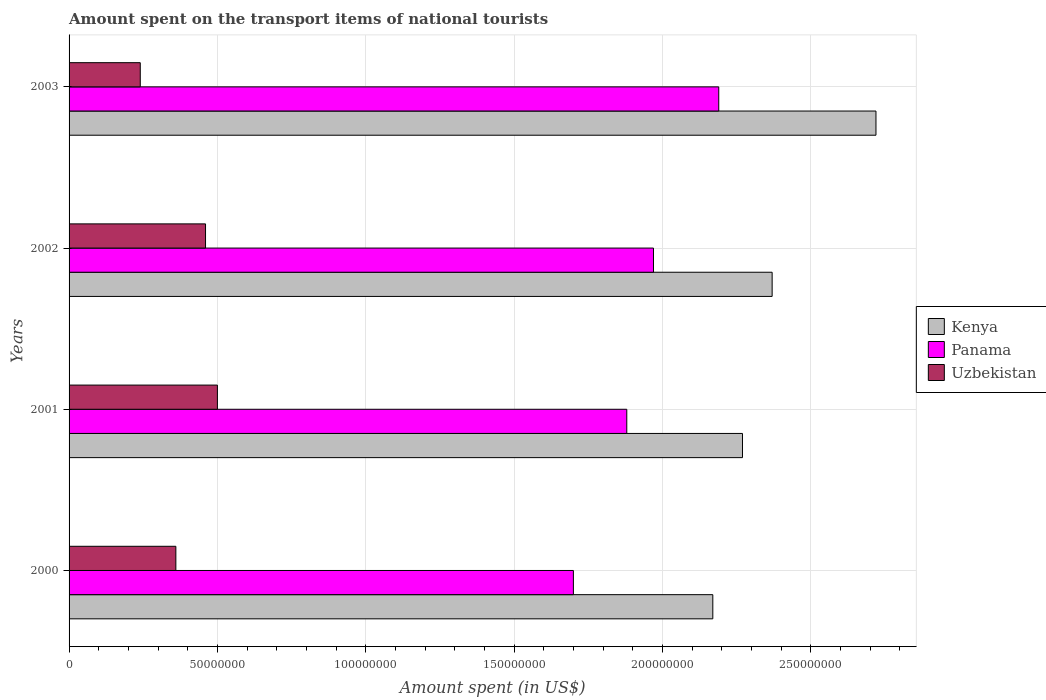How many different coloured bars are there?
Provide a short and direct response. 3. How many groups of bars are there?
Provide a short and direct response. 4. Are the number of bars per tick equal to the number of legend labels?
Give a very brief answer. Yes. How many bars are there on the 4th tick from the top?
Keep it short and to the point. 3. How many bars are there on the 2nd tick from the bottom?
Your answer should be compact. 3. What is the amount spent on the transport items of national tourists in Panama in 2003?
Ensure brevity in your answer.  2.19e+08. Across all years, what is the maximum amount spent on the transport items of national tourists in Uzbekistan?
Provide a short and direct response. 5.00e+07. Across all years, what is the minimum amount spent on the transport items of national tourists in Uzbekistan?
Your answer should be very brief. 2.40e+07. What is the total amount spent on the transport items of national tourists in Uzbekistan in the graph?
Offer a very short reply. 1.56e+08. What is the difference between the amount spent on the transport items of national tourists in Uzbekistan in 2002 and that in 2003?
Offer a very short reply. 2.20e+07. What is the average amount spent on the transport items of national tourists in Uzbekistan per year?
Offer a very short reply. 3.90e+07. In the year 2002, what is the difference between the amount spent on the transport items of national tourists in Uzbekistan and amount spent on the transport items of national tourists in Panama?
Ensure brevity in your answer.  -1.51e+08. What is the ratio of the amount spent on the transport items of national tourists in Uzbekistan in 2001 to that in 2002?
Ensure brevity in your answer.  1.09. Is the amount spent on the transport items of national tourists in Kenya in 2001 less than that in 2003?
Ensure brevity in your answer.  Yes. What is the difference between the highest and the second highest amount spent on the transport items of national tourists in Uzbekistan?
Give a very brief answer. 4.00e+06. What is the difference between the highest and the lowest amount spent on the transport items of national tourists in Panama?
Give a very brief answer. 4.90e+07. In how many years, is the amount spent on the transport items of national tourists in Uzbekistan greater than the average amount spent on the transport items of national tourists in Uzbekistan taken over all years?
Give a very brief answer. 2. What does the 2nd bar from the top in 2001 represents?
Keep it short and to the point. Panama. What does the 2nd bar from the bottom in 2000 represents?
Your answer should be very brief. Panama. Are all the bars in the graph horizontal?
Offer a very short reply. Yes. How many years are there in the graph?
Your response must be concise. 4. Are the values on the major ticks of X-axis written in scientific E-notation?
Offer a very short reply. No. Does the graph contain any zero values?
Ensure brevity in your answer.  No. How are the legend labels stacked?
Offer a very short reply. Vertical. What is the title of the graph?
Keep it short and to the point. Amount spent on the transport items of national tourists. What is the label or title of the X-axis?
Offer a terse response. Amount spent (in US$). What is the Amount spent (in US$) in Kenya in 2000?
Provide a succinct answer. 2.17e+08. What is the Amount spent (in US$) in Panama in 2000?
Give a very brief answer. 1.70e+08. What is the Amount spent (in US$) in Uzbekistan in 2000?
Your answer should be compact. 3.60e+07. What is the Amount spent (in US$) in Kenya in 2001?
Ensure brevity in your answer.  2.27e+08. What is the Amount spent (in US$) of Panama in 2001?
Ensure brevity in your answer.  1.88e+08. What is the Amount spent (in US$) of Uzbekistan in 2001?
Give a very brief answer. 5.00e+07. What is the Amount spent (in US$) of Kenya in 2002?
Your response must be concise. 2.37e+08. What is the Amount spent (in US$) in Panama in 2002?
Make the answer very short. 1.97e+08. What is the Amount spent (in US$) of Uzbekistan in 2002?
Provide a short and direct response. 4.60e+07. What is the Amount spent (in US$) of Kenya in 2003?
Your answer should be compact. 2.72e+08. What is the Amount spent (in US$) in Panama in 2003?
Keep it short and to the point. 2.19e+08. What is the Amount spent (in US$) of Uzbekistan in 2003?
Your answer should be very brief. 2.40e+07. Across all years, what is the maximum Amount spent (in US$) of Kenya?
Offer a terse response. 2.72e+08. Across all years, what is the maximum Amount spent (in US$) of Panama?
Keep it short and to the point. 2.19e+08. Across all years, what is the minimum Amount spent (in US$) in Kenya?
Give a very brief answer. 2.17e+08. Across all years, what is the minimum Amount spent (in US$) in Panama?
Provide a short and direct response. 1.70e+08. Across all years, what is the minimum Amount spent (in US$) in Uzbekistan?
Make the answer very short. 2.40e+07. What is the total Amount spent (in US$) of Kenya in the graph?
Your answer should be very brief. 9.53e+08. What is the total Amount spent (in US$) of Panama in the graph?
Give a very brief answer. 7.74e+08. What is the total Amount spent (in US$) in Uzbekistan in the graph?
Make the answer very short. 1.56e+08. What is the difference between the Amount spent (in US$) in Kenya in 2000 and that in 2001?
Provide a succinct answer. -1.00e+07. What is the difference between the Amount spent (in US$) of Panama in 2000 and that in 2001?
Keep it short and to the point. -1.80e+07. What is the difference between the Amount spent (in US$) of Uzbekistan in 2000 and that in 2001?
Your answer should be very brief. -1.40e+07. What is the difference between the Amount spent (in US$) in Kenya in 2000 and that in 2002?
Your answer should be very brief. -2.00e+07. What is the difference between the Amount spent (in US$) of Panama in 2000 and that in 2002?
Offer a very short reply. -2.70e+07. What is the difference between the Amount spent (in US$) in Uzbekistan in 2000 and that in 2002?
Provide a short and direct response. -1.00e+07. What is the difference between the Amount spent (in US$) of Kenya in 2000 and that in 2003?
Keep it short and to the point. -5.50e+07. What is the difference between the Amount spent (in US$) in Panama in 2000 and that in 2003?
Give a very brief answer. -4.90e+07. What is the difference between the Amount spent (in US$) of Kenya in 2001 and that in 2002?
Provide a short and direct response. -1.00e+07. What is the difference between the Amount spent (in US$) of Panama in 2001 and that in 2002?
Provide a short and direct response. -9.00e+06. What is the difference between the Amount spent (in US$) in Kenya in 2001 and that in 2003?
Your response must be concise. -4.50e+07. What is the difference between the Amount spent (in US$) in Panama in 2001 and that in 2003?
Provide a short and direct response. -3.10e+07. What is the difference between the Amount spent (in US$) in Uzbekistan in 2001 and that in 2003?
Keep it short and to the point. 2.60e+07. What is the difference between the Amount spent (in US$) in Kenya in 2002 and that in 2003?
Provide a short and direct response. -3.50e+07. What is the difference between the Amount spent (in US$) of Panama in 2002 and that in 2003?
Offer a very short reply. -2.20e+07. What is the difference between the Amount spent (in US$) in Uzbekistan in 2002 and that in 2003?
Your response must be concise. 2.20e+07. What is the difference between the Amount spent (in US$) in Kenya in 2000 and the Amount spent (in US$) in Panama in 2001?
Your answer should be compact. 2.90e+07. What is the difference between the Amount spent (in US$) of Kenya in 2000 and the Amount spent (in US$) of Uzbekistan in 2001?
Ensure brevity in your answer.  1.67e+08. What is the difference between the Amount spent (in US$) in Panama in 2000 and the Amount spent (in US$) in Uzbekistan in 2001?
Your response must be concise. 1.20e+08. What is the difference between the Amount spent (in US$) in Kenya in 2000 and the Amount spent (in US$) in Panama in 2002?
Provide a succinct answer. 2.00e+07. What is the difference between the Amount spent (in US$) in Kenya in 2000 and the Amount spent (in US$) in Uzbekistan in 2002?
Keep it short and to the point. 1.71e+08. What is the difference between the Amount spent (in US$) of Panama in 2000 and the Amount spent (in US$) of Uzbekistan in 2002?
Your answer should be very brief. 1.24e+08. What is the difference between the Amount spent (in US$) of Kenya in 2000 and the Amount spent (in US$) of Panama in 2003?
Make the answer very short. -2.00e+06. What is the difference between the Amount spent (in US$) of Kenya in 2000 and the Amount spent (in US$) of Uzbekistan in 2003?
Offer a very short reply. 1.93e+08. What is the difference between the Amount spent (in US$) in Panama in 2000 and the Amount spent (in US$) in Uzbekistan in 2003?
Your answer should be compact. 1.46e+08. What is the difference between the Amount spent (in US$) of Kenya in 2001 and the Amount spent (in US$) of Panama in 2002?
Your answer should be very brief. 3.00e+07. What is the difference between the Amount spent (in US$) in Kenya in 2001 and the Amount spent (in US$) in Uzbekistan in 2002?
Ensure brevity in your answer.  1.81e+08. What is the difference between the Amount spent (in US$) in Panama in 2001 and the Amount spent (in US$) in Uzbekistan in 2002?
Provide a short and direct response. 1.42e+08. What is the difference between the Amount spent (in US$) of Kenya in 2001 and the Amount spent (in US$) of Panama in 2003?
Your response must be concise. 8.00e+06. What is the difference between the Amount spent (in US$) of Kenya in 2001 and the Amount spent (in US$) of Uzbekistan in 2003?
Your answer should be compact. 2.03e+08. What is the difference between the Amount spent (in US$) in Panama in 2001 and the Amount spent (in US$) in Uzbekistan in 2003?
Your answer should be compact. 1.64e+08. What is the difference between the Amount spent (in US$) in Kenya in 2002 and the Amount spent (in US$) in Panama in 2003?
Offer a very short reply. 1.80e+07. What is the difference between the Amount spent (in US$) in Kenya in 2002 and the Amount spent (in US$) in Uzbekistan in 2003?
Offer a terse response. 2.13e+08. What is the difference between the Amount spent (in US$) of Panama in 2002 and the Amount spent (in US$) of Uzbekistan in 2003?
Your answer should be very brief. 1.73e+08. What is the average Amount spent (in US$) in Kenya per year?
Make the answer very short. 2.38e+08. What is the average Amount spent (in US$) of Panama per year?
Offer a very short reply. 1.94e+08. What is the average Amount spent (in US$) in Uzbekistan per year?
Your answer should be very brief. 3.90e+07. In the year 2000, what is the difference between the Amount spent (in US$) of Kenya and Amount spent (in US$) of Panama?
Your answer should be very brief. 4.70e+07. In the year 2000, what is the difference between the Amount spent (in US$) of Kenya and Amount spent (in US$) of Uzbekistan?
Ensure brevity in your answer.  1.81e+08. In the year 2000, what is the difference between the Amount spent (in US$) of Panama and Amount spent (in US$) of Uzbekistan?
Keep it short and to the point. 1.34e+08. In the year 2001, what is the difference between the Amount spent (in US$) of Kenya and Amount spent (in US$) of Panama?
Offer a very short reply. 3.90e+07. In the year 2001, what is the difference between the Amount spent (in US$) in Kenya and Amount spent (in US$) in Uzbekistan?
Your answer should be compact. 1.77e+08. In the year 2001, what is the difference between the Amount spent (in US$) in Panama and Amount spent (in US$) in Uzbekistan?
Offer a very short reply. 1.38e+08. In the year 2002, what is the difference between the Amount spent (in US$) of Kenya and Amount spent (in US$) of Panama?
Provide a short and direct response. 4.00e+07. In the year 2002, what is the difference between the Amount spent (in US$) in Kenya and Amount spent (in US$) in Uzbekistan?
Keep it short and to the point. 1.91e+08. In the year 2002, what is the difference between the Amount spent (in US$) of Panama and Amount spent (in US$) of Uzbekistan?
Offer a very short reply. 1.51e+08. In the year 2003, what is the difference between the Amount spent (in US$) in Kenya and Amount spent (in US$) in Panama?
Make the answer very short. 5.30e+07. In the year 2003, what is the difference between the Amount spent (in US$) of Kenya and Amount spent (in US$) of Uzbekistan?
Make the answer very short. 2.48e+08. In the year 2003, what is the difference between the Amount spent (in US$) of Panama and Amount spent (in US$) of Uzbekistan?
Provide a short and direct response. 1.95e+08. What is the ratio of the Amount spent (in US$) of Kenya in 2000 to that in 2001?
Your answer should be compact. 0.96. What is the ratio of the Amount spent (in US$) in Panama in 2000 to that in 2001?
Offer a very short reply. 0.9. What is the ratio of the Amount spent (in US$) in Uzbekistan in 2000 to that in 2001?
Your answer should be very brief. 0.72. What is the ratio of the Amount spent (in US$) in Kenya in 2000 to that in 2002?
Offer a terse response. 0.92. What is the ratio of the Amount spent (in US$) of Panama in 2000 to that in 2002?
Your answer should be very brief. 0.86. What is the ratio of the Amount spent (in US$) of Uzbekistan in 2000 to that in 2002?
Offer a very short reply. 0.78. What is the ratio of the Amount spent (in US$) of Kenya in 2000 to that in 2003?
Offer a terse response. 0.8. What is the ratio of the Amount spent (in US$) in Panama in 2000 to that in 2003?
Provide a succinct answer. 0.78. What is the ratio of the Amount spent (in US$) in Uzbekistan in 2000 to that in 2003?
Offer a very short reply. 1.5. What is the ratio of the Amount spent (in US$) in Kenya in 2001 to that in 2002?
Provide a succinct answer. 0.96. What is the ratio of the Amount spent (in US$) in Panama in 2001 to that in 2002?
Make the answer very short. 0.95. What is the ratio of the Amount spent (in US$) in Uzbekistan in 2001 to that in 2002?
Ensure brevity in your answer.  1.09. What is the ratio of the Amount spent (in US$) in Kenya in 2001 to that in 2003?
Keep it short and to the point. 0.83. What is the ratio of the Amount spent (in US$) of Panama in 2001 to that in 2003?
Your answer should be compact. 0.86. What is the ratio of the Amount spent (in US$) in Uzbekistan in 2001 to that in 2003?
Provide a succinct answer. 2.08. What is the ratio of the Amount spent (in US$) of Kenya in 2002 to that in 2003?
Your response must be concise. 0.87. What is the ratio of the Amount spent (in US$) of Panama in 2002 to that in 2003?
Keep it short and to the point. 0.9. What is the ratio of the Amount spent (in US$) in Uzbekistan in 2002 to that in 2003?
Ensure brevity in your answer.  1.92. What is the difference between the highest and the second highest Amount spent (in US$) in Kenya?
Make the answer very short. 3.50e+07. What is the difference between the highest and the second highest Amount spent (in US$) of Panama?
Your answer should be compact. 2.20e+07. What is the difference between the highest and the lowest Amount spent (in US$) of Kenya?
Offer a terse response. 5.50e+07. What is the difference between the highest and the lowest Amount spent (in US$) in Panama?
Provide a succinct answer. 4.90e+07. What is the difference between the highest and the lowest Amount spent (in US$) in Uzbekistan?
Provide a short and direct response. 2.60e+07. 